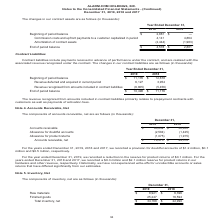According to Alarmcom Holdings's financial document, How much was the provision for doubtful accounts in 2019? According to the financial document, $1.2 million (in millions). The relevant text states: ", we recorded a provision for doubtful accounts of $1.2 million, $0.1 million and $0.5 million, respectively...." Also, Which years does the table provide information for accounts receivable, net for? The document shows two values: 2019 and 2018. From the document: "Year Ended December 31, 2019 2018 Beginning of period balance $ 2,881 $ — Commission costs and upfront payments to a customer ca Year Ended December 3..." Also, What was the reduction to the reserve for product returns in 2019? According to the financial document, $0.1 million (in millions). The relevant text states: "a provision for doubtful accounts of $1.2 million, $0.1 million and $0.5 million, respectively...." Also, can you calculate: What was the change in Accounts receivable between 2018 and 2019? Based on the calculation: 80,032-52,850, the result is 27182 (in thousands). This is based on the information: "December 31, 2019 2018 Accounts receivable $ 80,032 $ 52,850 Allowance for doubtful accounts (2,584) (1,425) Allowance for product returns (1,075) (1,9 mber 31, 2019 2018 Accounts receivable $ 80,032 ..." The key data points involved are: 52,850, 80,032. Also, How many years did net accounts receivable exceed $50,000 thousand? Based on the analysis, there are 1 instances. The counting process: 2019. Also, can you calculate: What was the percentage change in allowance for product returns between 2018 and 2019? To answer this question, I need to perform calculations using the financial data. The calculation is: (-1,075+1,915)/-1,915, which equals -43.86 (percentage). This is based on the information: "ts (2,584) (1,425) Allowance for product returns (1,075) (1,915) Accounts receivable, net $ 76,373 $ 49,510 4) (1,425) Allowance for product returns (1,075) (1,915) Accounts receivable, net $ 76,373 $..." The key data points involved are: 1,075, 1,915. 